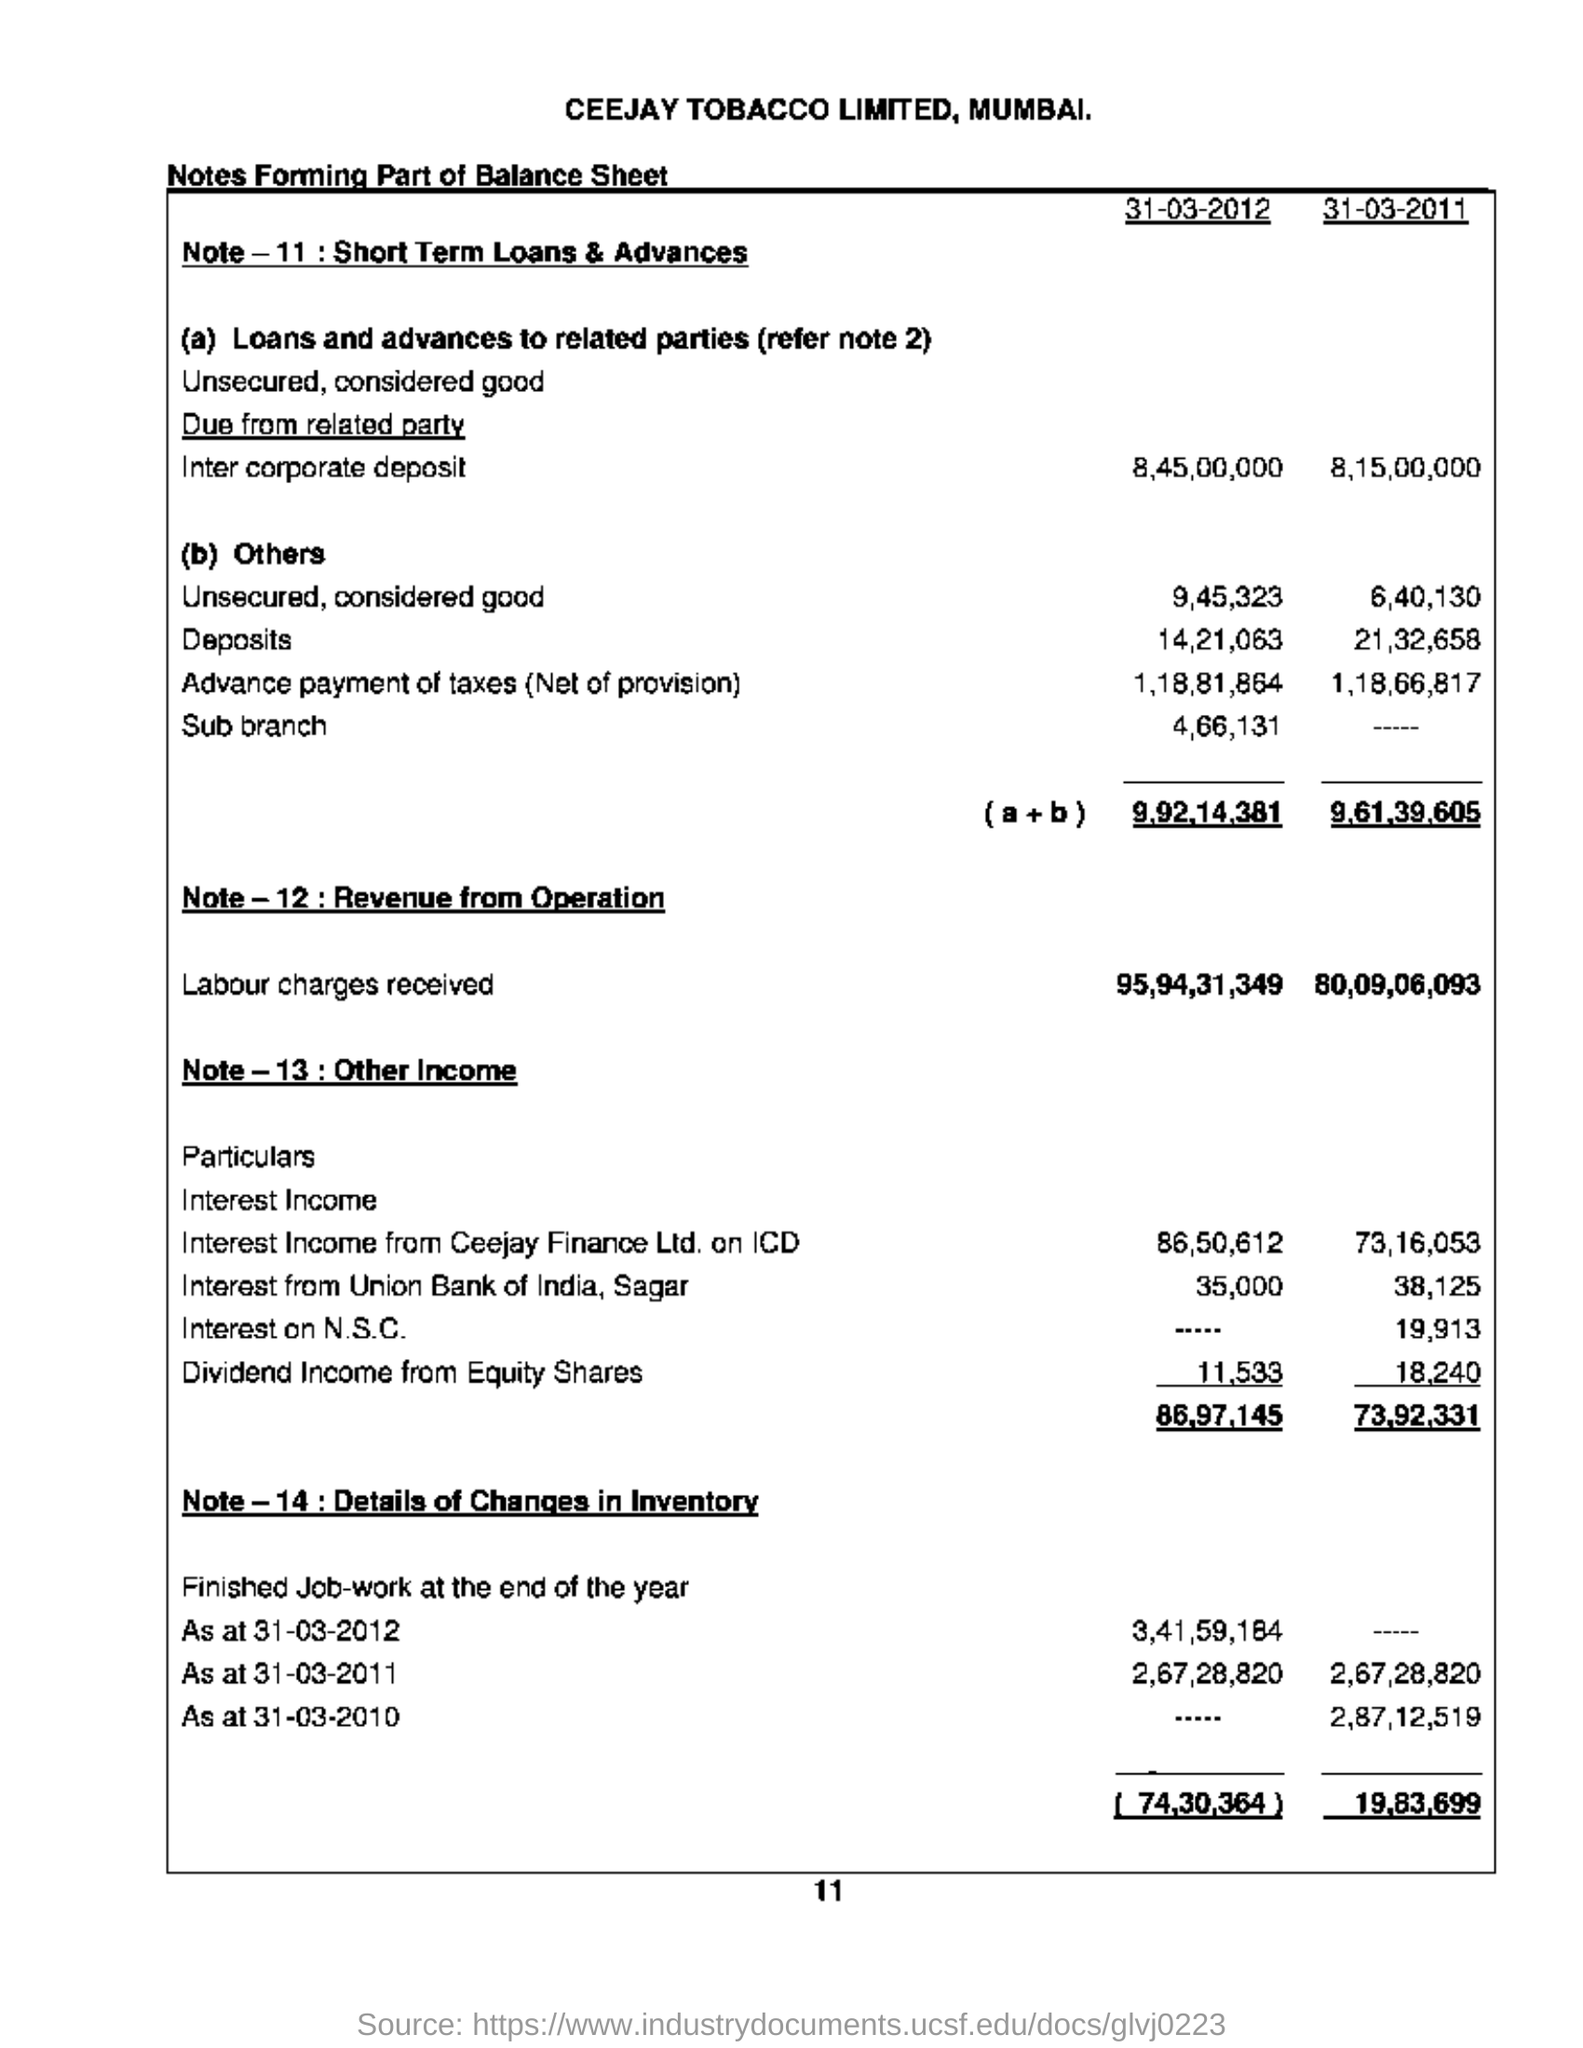Point out several critical features in this image. The amount of labor charges mentioned in 2012 was 95,94,31,349. In 2011, the amount of other income mentioned was 73,92,331. The location of the tobacco company is Mumbai. The balance sheet mentions CEEJAY TOBACCO LIMITED. 